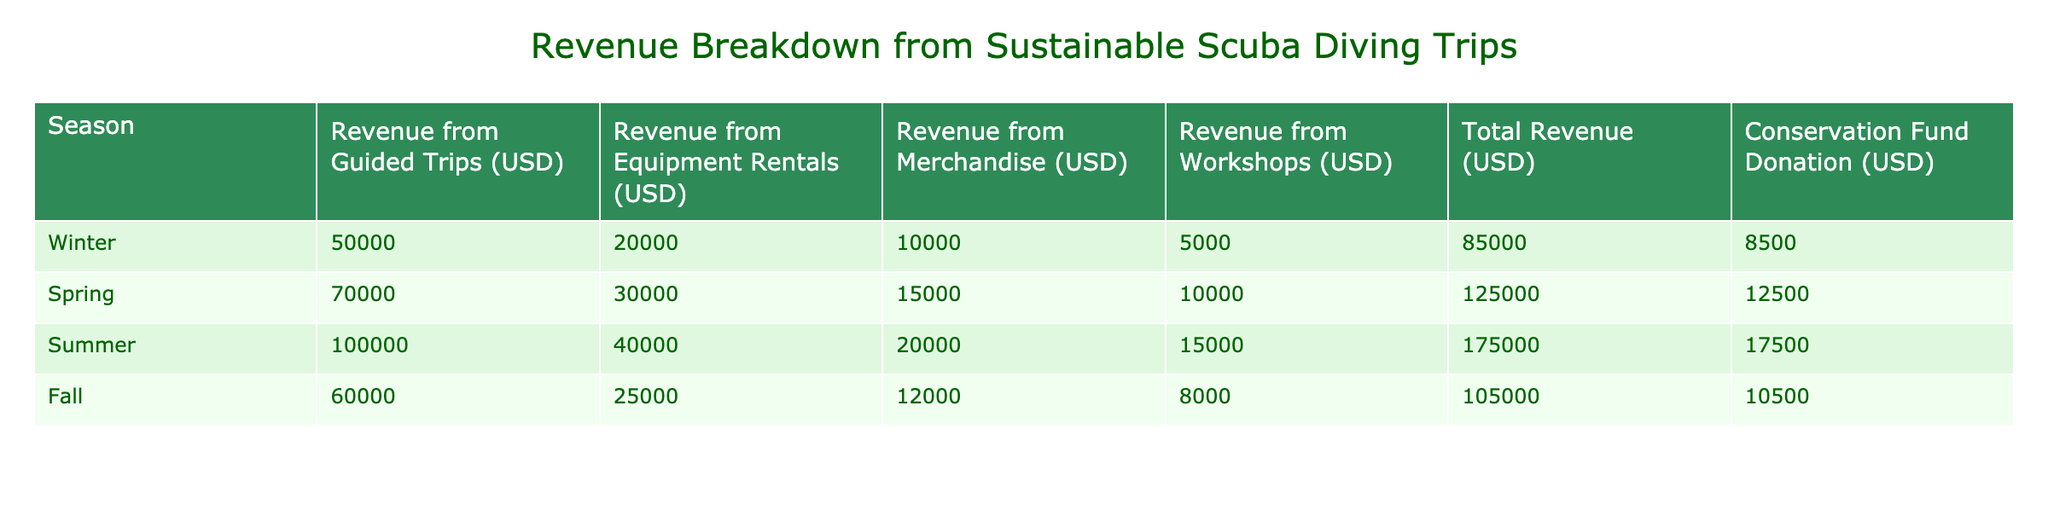What is the total revenue from Summer trips? From the table, the total revenue for the Summer season is directly listed under the Total Revenue column. The value for Summer is 175000 USD.
Answer: 175000 USD Which season had the highest revenue from workshops? By reviewing the Revenue from Workshops column, the values are: Winter (5000), Spring (10000), Summer (15000), and Fall (8000). The highest value is 15000 USD from the Summer season.
Answer: Summer What is the combined revenue from guided trips across all seasons? To find the combined revenue from guided trips, we add the values from the Guided Trips column: 50000 (Winter) + 70000 (Spring) + 100000 (Summer) + 60000 (Fall) = 285000 USD.
Answer: 285000 USD Is the total revenue from the Fall season more than the conservation fund donation? The total revenue for Fall as shown in the table is 105000 USD, and the conservation fund donation for that season is 10500 USD. Since 105000 USD is greater than 10500 USD, the statement is true.
Answer: Yes What is the average revenue from merchandise during all seasons? The revenue from Merchandise per season is: Winter (10000), Spring (15000), Summer (20000), and Fall (12000). Summing these gives us 10000 + 15000 + 20000 + 12000 = 57000 USD. To find the average, we divide by the number of seasons (4): 57000 / 4 = 14250 USD.
Answer: 14250 USD Which season contributed the least to the conservation fund? Checking the Conservation Fund Donation column: Winter (8500), Spring (12500), Summer (17500), Fall (10500). The least contribution is 8500 USD from the Winter season.
Answer: Winter What was the total revenue from equipment rentals in Spring and Fall combined? The revenue from Equipment Rentals in Spring is 30000 USD and in Fall is 25000 USD. By adding these together, we get 30000 + 25000 = 55000 USD.
Answer: 55000 USD Which season had the highest revenue from guided trips and what is that amount? Examining the Guided Trips column: Winter (50000), Spring (70000), Summer (100000), and Fall (60000). The highest revenue is 100000 USD from the Summer season.
Answer: Summer, 100000 USD 